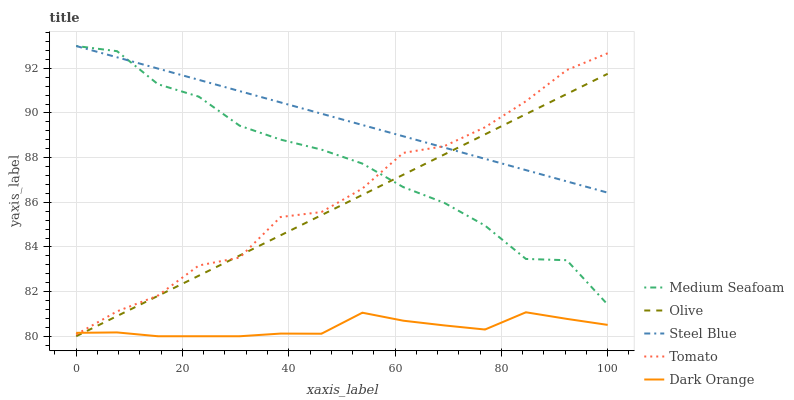Does Dark Orange have the minimum area under the curve?
Answer yes or no. Yes. Does Steel Blue have the maximum area under the curve?
Answer yes or no. Yes. Does Tomato have the minimum area under the curve?
Answer yes or no. No. Does Tomato have the maximum area under the curve?
Answer yes or no. No. Is Olive the smoothest?
Answer yes or no. Yes. Is Tomato the roughest?
Answer yes or no. Yes. Is Medium Seafoam the smoothest?
Answer yes or no. No. Is Medium Seafoam the roughest?
Answer yes or no. No. Does Olive have the lowest value?
Answer yes or no. Yes. Does Tomato have the lowest value?
Answer yes or no. No. Does Steel Blue have the highest value?
Answer yes or no. Yes. Does Tomato have the highest value?
Answer yes or no. No. Is Dark Orange less than Steel Blue?
Answer yes or no. Yes. Is Medium Seafoam greater than Dark Orange?
Answer yes or no. Yes. Does Olive intersect Dark Orange?
Answer yes or no. Yes. Is Olive less than Dark Orange?
Answer yes or no. No. Is Olive greater than Dark Orange?
Answer yes or no. No. Does Dark Orange intersect Steel Blue?
Answer yes or no. No. 